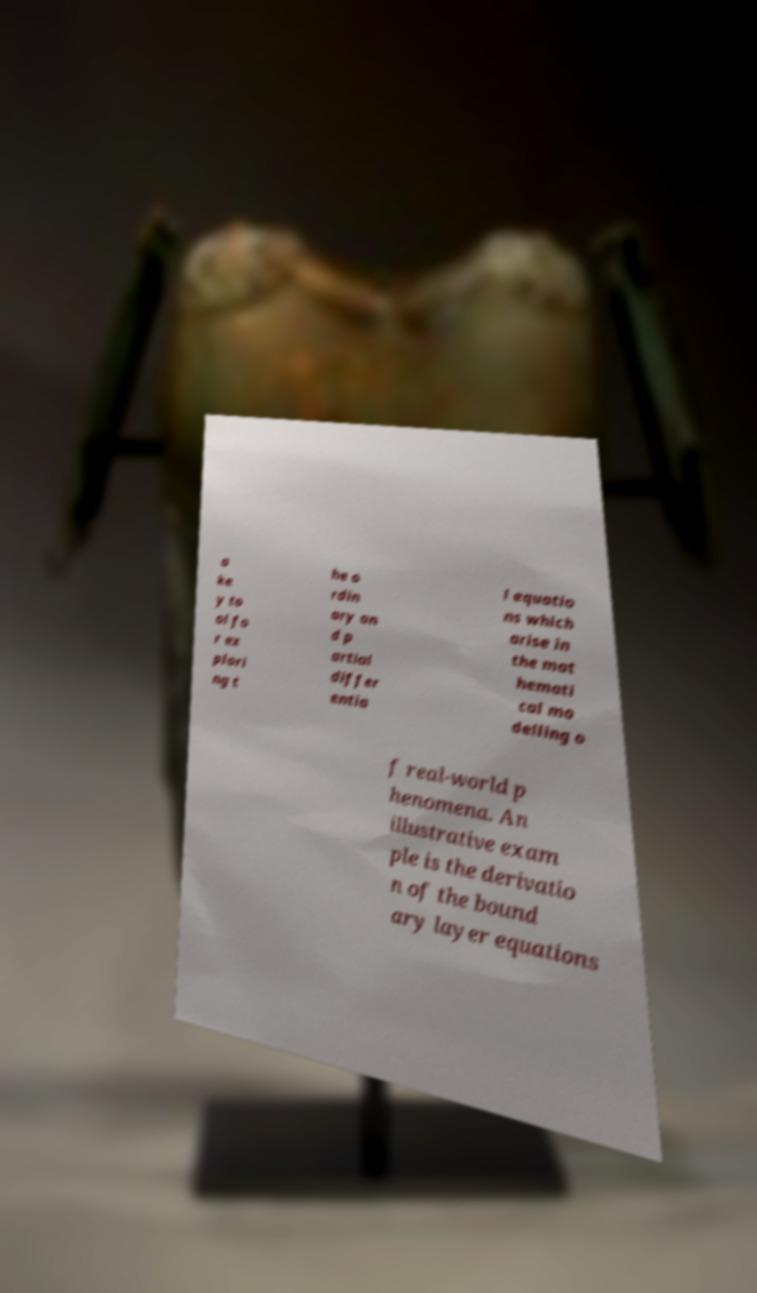Can you read and provide the text displayed in the image?This photo seems to have some interesting text. Can you extract and type it out for me? a ke y to ol fo r ex plori ng t he o rdin ary an d p artial differ entia l equatio ns which arise in the mat hemati cal mo delling o f real-world p henomena. An illustrative exam ple is the derivatio n of the bound ary layer equations 